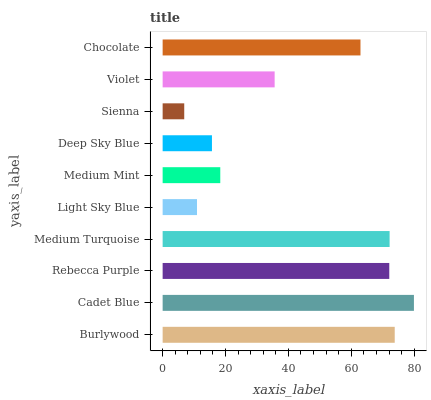Is Sienna the minimum?
Answer yes or no. Yes. Is Cadet Blue the maximum?
Answer yes or no. Yes. Is Rebecca Purple the minimum?
Answer yes or no. No. Is Rebecca Purple the maximum?
Answer yes or no. No. Is Cadet Blue greater than Rebecca Purple?
Answer yes or no. Yes. Is Rebecca Purple less than Cadet Blue?
Answer yes or no. Yes. Is Rebecca Purple greater than Cadet Blue?
Answer yes or no. No. Is Cadet Blue less than Rebecca Purple?
Answer yes or no. No. Is Chocolate the high median?
Answer yes or no. Yes. Is Violet the low median?
Answer yes or no. Yes. Is Violet the high median?
Answer yes or no. No. Is Sienna the low median?
Answer yes or no. No. 